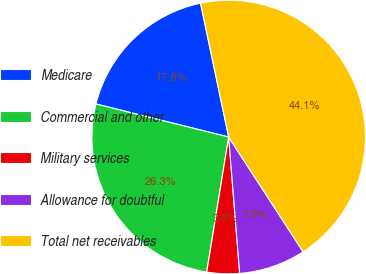<chart> <loc_0><loc_0><loc_500><loc_500><pie_chart><fcel>Medicare<fcel>Commercial and other<fcel>Military services<fcel>Allowance for doubtful<fcel>Total net receivables<nl><fcel>17.82%<fcel>26.32%<fcel>3.85%<fcel>7.88%<fcel>44.14%<nl></chart> 